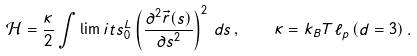Convert formula to latex. <formula><loc_0><loc_0><loc_500><loc_500>\mathcal { H } = \frac { \kappa } { 2 } \int \lim i t s _ { 0 } ^ { L } \left ( \frac { \partial ^ { 2 } \vec { r } ( s ) } { \partial s ^ { 2 } } \right ) ^ { 2 } \, d s \, , \quad \kappa = k _ { B } T \ell _ { p } \, ( d = 3 ) \, .</formula> 